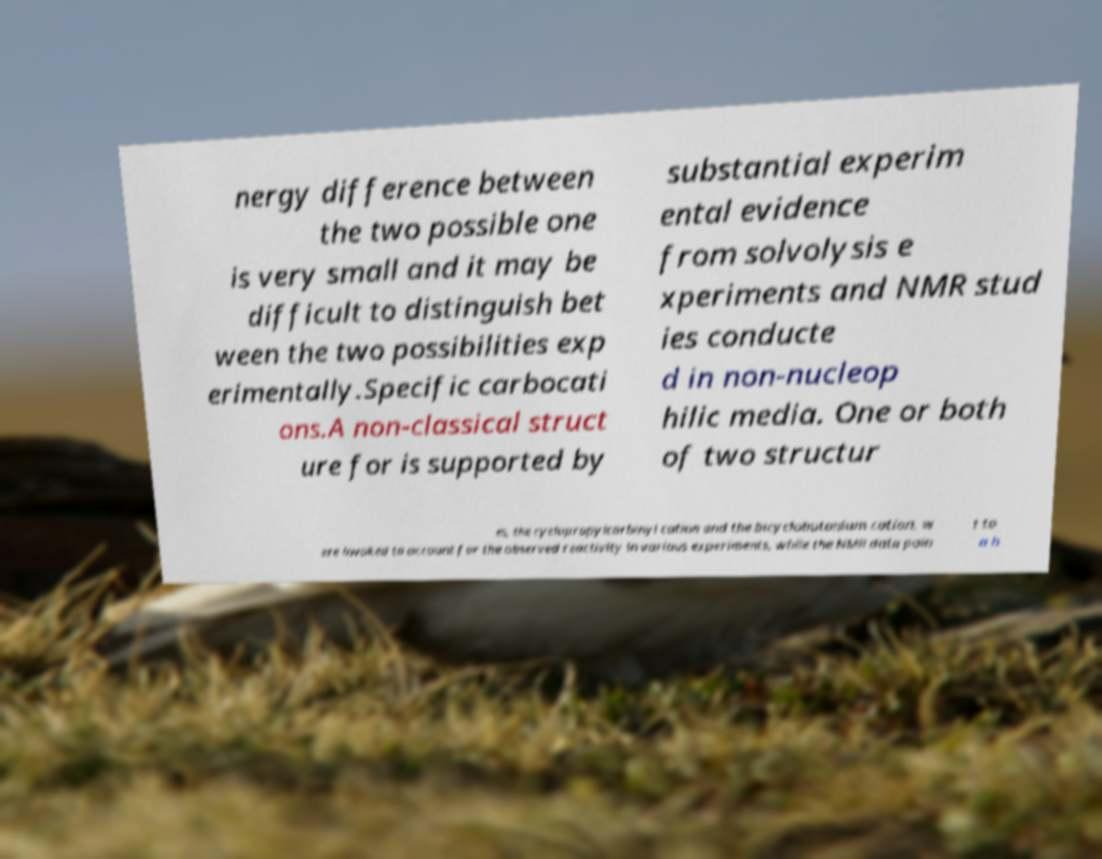Can you read and provide the text displayed in the image?This photo seems to have some interesting text. Can you extract and type it out for me? nergy difference between the two possible one is very small and it may be difficult to distinguish bet ween the two possibilities exp erimentally.Specific carbocati ons.A non-classical struct ure for is supported by substantial experim ental evidence from solvolysis e xperiments and NMR stud ies conducte d in non-nucleop hilic media. One or both of two structur es, the cyclopropylcarbinyl cation and the bicyclobutonium cation, w ere invoked to account for the observed reactivity in various experiments, while the NMR data poin t to a h 